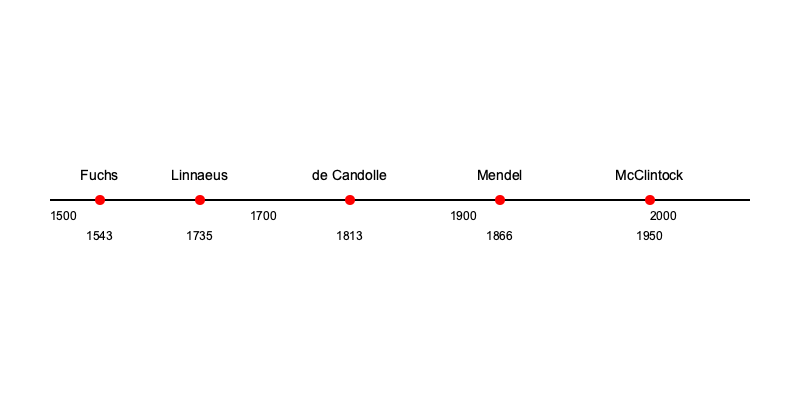Based on the timeline, which botanist's contribution came closest to the midpoint between Linnaeus's and Mendel's work? To determine which botanist's contribution is closest to the midpoint between Linnaeus and Mendel, we need to follow these steps:

1. Identify the years for Linnaeus and Mendel:
   Linnaeus: 1735
   Mendel: 1866

2. Calculate the midpoint year:
   Midpoint = (1735 + 1866) / 2 = 1800.5

3. List the years for each botanist between Linnaeus and Mendel:
   de Candolle: 1813

4. Compare de Candolle's year to the midpoint:
   The difference between de Candolle's year and the midpoint is:
   |1813 - 1800.5| = 12.5 years

5. Check if any other botanist is closer to the midpoint:
   There are no other botanists listed between Linnaeus and Mendel.

Therefore, de Candolle's contribution in 1813 is closest to the midpoint between Linnaeus's and Mendel's work.
Answer: de Candolle 